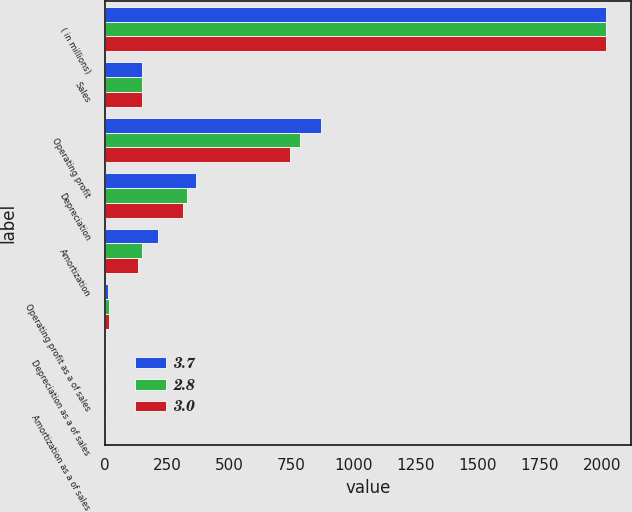<chart> <loc_0><loc_0><loc_500><loc_500><stacked_bar_chart><ecel><fcel>( in millions)<fcel>Sales<fcel>Operating profit<fcel>Depreciation<fcel>Amortization<fcel>Operating profit as a of sales<fcel>Depreciation as a of sales<fcel>Amortization as a of sales<nl><fcel>3.7<fcel>2017<fcel>149.4<fcel>871.6<fcel>368.1<fcel>213.4<fcel>14.9<fcel>6.3<fcel>3.7<nl><fcel>2.8<fcel>2016<fcel>149.4<fcel>786.4<fcel>332.1<fcel>149.4<fcel>15.6<fcel>6.6<fcel>3<nl><fcel>3<fcel>2015<fcel>149.4<fcel>746.2<fcel>314.9<fcel>134.8<fcel>15.4<fcel>6.5<fcel>2.8<nl></chart> 